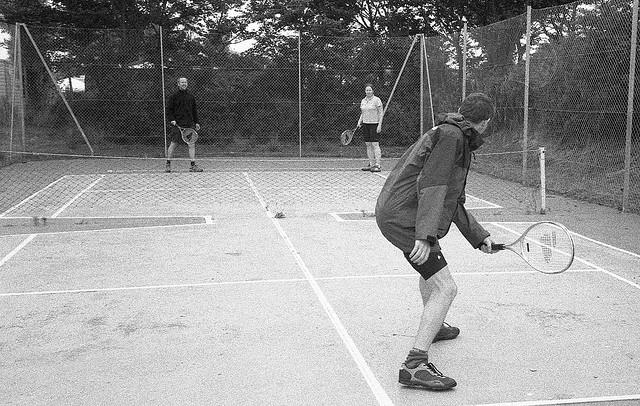What is the fence made of?
Concise answer only. Chain link. What kind of park are they in?
Quick response, please. Tennis. What color is the picture?
Short answer required. Black and white. What are the men holding?
Quick response, please. Rackets. What are the boys doing?
Answer briefly. Playing tennis. 